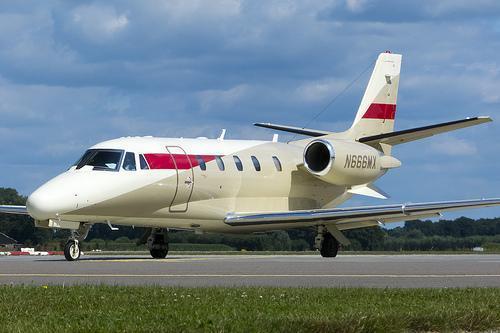How many planes are on the runway?
Give a very brief answer. 1. How many call letters are on the side of this plane?
Give a very brief answer. 6. How many green planes are there?
Give a very brief answer. 0. 